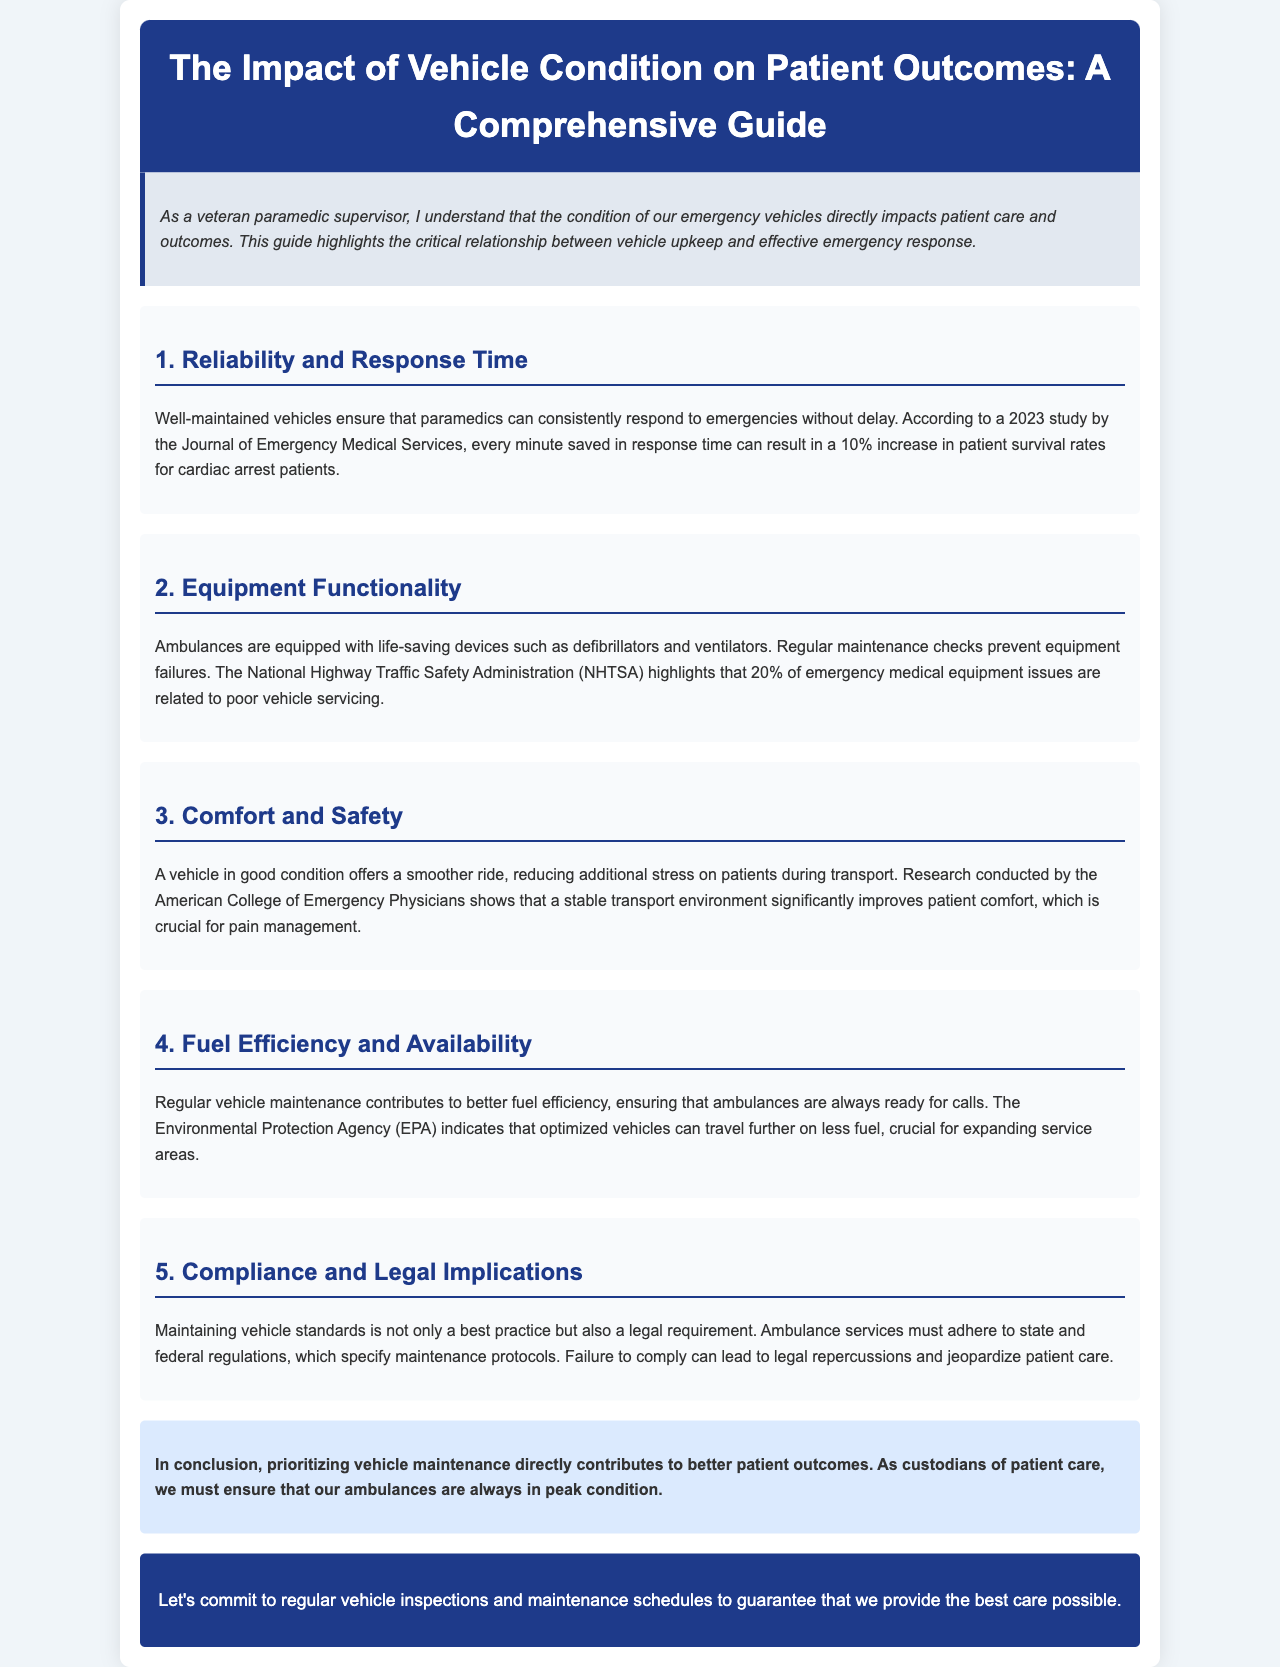What is the title of the document? The title is provided in the header of the document, which states the theme of the guide.
Answer: The Impact of Vehicle Condition on Patient Outcomes: A Comprehensive Guide According to the 2023 study, how much can patient survival rates increase for cardiac arrest patients with each minute saved? The document references a study indicating a specific percentage increase in survival rates, highlighting the importance of response time.
Answer: 10% What percentage of emergency medical equipment issues are related to poor vehicle servicing? The document cites a statistic regarding equipment issues stemming from inadequate vehicle maintenance.
Answer: 20% Which organization highlights the benefits of a stable transport environment to improve patient comfort? The document attributes research related to patient comfort improvement to a specific organization, reflecting its relevance to the topic.
Answer: American College of Emergency Physicians What are the consequences of failing to comply with maintenance protocols? The document mentions the repercussions of non-compliance with vehicle maintenance regulations, impacting patient care.
Answer: Legal repercussions What is the primary focus of the document? The document clearly emphasizes the crucial relationship between vehicle condition and patient care outcomes.
Answer: Vehicle maintenance How does regular vehicle maintenance affect fuel efficiency? The document outlines the positive impact of maintenance on fuel consumption, which is vital for ambulance readiness.
Answer: Better fuel efficiency What type of vehicle issues does the National Highway Traffic Safety Administration report are common? The document explains that a specific percentage of emergency equipment issues are tied to vehicle service quality.
Answer: Emergency medical equipment issues 